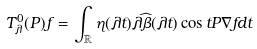<formula> <loc_0><loc_0><loc_500><loc_500>T _ { \lambda } ^ { 0 } ( P ) f = \int _ { \mathbb { R } } \eta ( \lambda t ) \lambda \widehat { \beta } ( \lambda t ) \cos { t P } \nabla f d t</formula> 